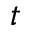Convert formula to latex. <formula><loc_0><loc_0><loc_500><loc_500>t</formula> 